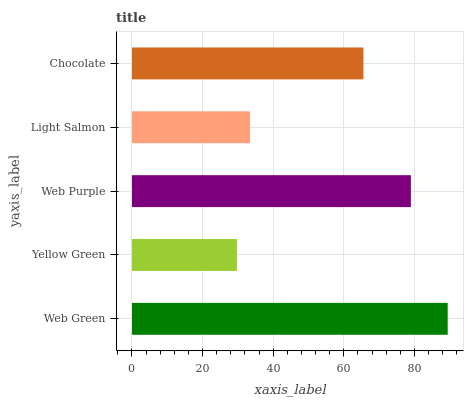Is Yellow Green the minimum?
Answer yes or no. Yes. Is Web Green the maximum?
Answer yes or no. Yes. Is Web Purple the minimum?
Answer yes or no. No. Is Web Purple the maximum?
Answer yes or no. No. Is Web Purple greater than Yellow Green?
Answer yes or no. Yes. Is Yellow Green less than Web Purple?
Answer yes or no. Yes. Is Yellow Green greater than Web Purple?
Answer yes or no. No. Is Web Purple less than Yellow Green?
Answer yes or no. No. Is Chocolate the high median?
Answer yes or no. Yes. Is Chocolate the low median?
Answer yes or no. Yes. Is Yellow Green the high median?
Answer yes or no. No. Is Web Purple the low median?
Answer yes or no. No. 